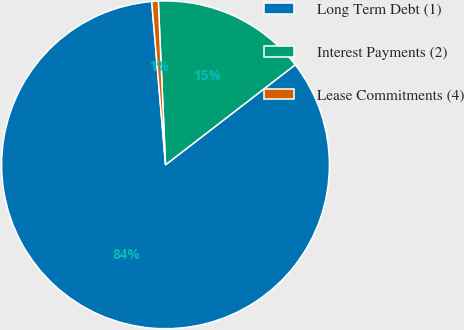<chart> <loc_0><loc_0><loc_500><loc_500><pie_chart><fcel>Long Term Debt (1)<fcel>Interest Payments (2)<fcel>Lease Commitments (4)<nl><fcel>84.11%<fcel>15.24%<fcel>0.64%<nl></chart> 